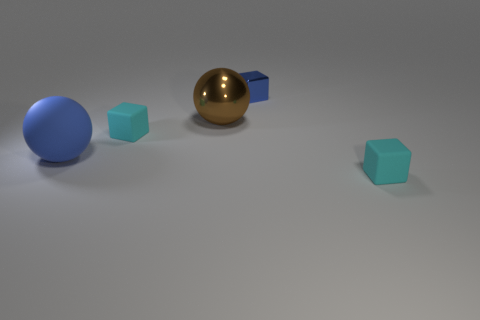There is a blue sphere that is the same size as the brown metal thing; what is it made of?
Offer a terse response. Rubber. What number of cyan matte cylinders are there?
Give a very brief answer. 0. What is the size of the metal ball on the left side of the small metallic object?
Give a very brief answer. Large. Is the number of big metallic things that are to the left of the big blue matte object the same as the number of big brown metallic spheres?
Your answer should be very brief. No. Are there any small cyan things of the same shape as the brown metallic object?
Your response must be concise. No. What shape is the object that is both to the right of the large brown thing and behind the matte sphere?
Provide a short and direct response. Cube. Are the brown thing and the tiny cyan object that is to the left of the large brown sphere made of the same material?
Keep it short and to the point. No. There is a large brown sphere; are there any big brown spheres on the right side of it?
Provide a succinct answer. No. How many objects are blue matte things or tiny rubber things on the right side of the tiny metallic block?
Your answer should be compact. 2. What is the color of the rubber ball that is in front of the blue object that is behind the large blue thing?
Ensure brevity in your answer.  Blue. 